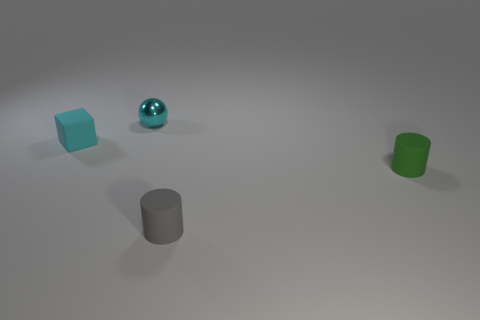Is there a object in front of the small matte cylinder that is in front of the tiny cylinder behind the gray object?
Give a very brief answer. No. What number of other spheres have the same size as the shiny ball?
Keep it short and to the point. 0. What material is the other tiny object that is the same shape as the green object?
Your response must be concise. Rubber. What is the shape of the tiny rubber object that is in front of the tiny rubber cube and on the left side of the green rubber thing?
Make the answer very short. Cylinder. There is a small thing to the right of the gray cylinder; what is its shape?
Give a very brief answer. Cylinder. How many small cylinders are to the left of the green thing and behind the small gray matte cylinder?
Provide a short and direct response. 0. There is a gray cylinder; does it have the same size as the thing on the left side of the tiny metal ball?
Provide a succinct answer. Yes. What size is the matte object that is to the left of the small cyan object that is behind the small cyan thing that is to the left of the ball?
Provide a succinct answer. Small. There is a cyan thing right of the cyan matte cube; how big is it?
Provide a short and direct response. Small. There is a tiny green object that is made of the same material as the gray cylinder; what is its shape?
Give a very brief answer. Cylinder. 